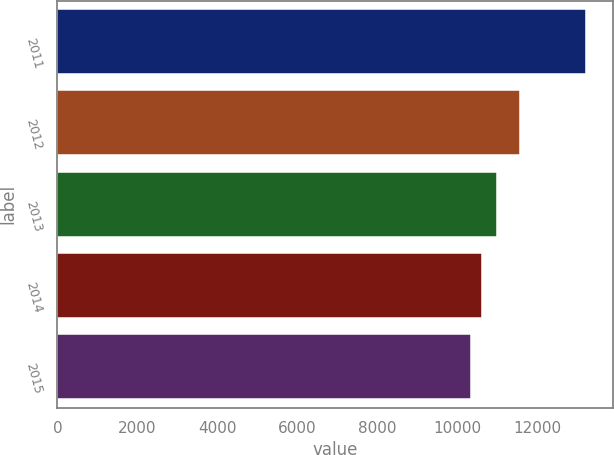Convert chart to OTSL. <chart><loc_0><loc_0><loc_500><loc_500><bar_chart><fcel>2011<fcel>2012<fcel>2013<fcel>2014<fcel>2015<nl><fcel>13235<fcel>11565<fcel>11008<fcel>10633.1<fcel>10344<nl></chart> 